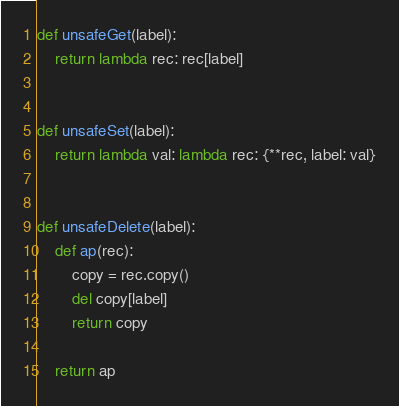<code> <loc_0><loc_0><loc_500><loc_500><_Python_>def unsafeGet(label):
    return lambda rec: rec[label]


def unsafeSet(label):
    return lambda val: lambda rec: {**rec, label: val}


def unsafeDelete(label):
    def ap(rec):
        copy = rec.copy()
        del copy[label]
        return copy

    return ap
</code> 